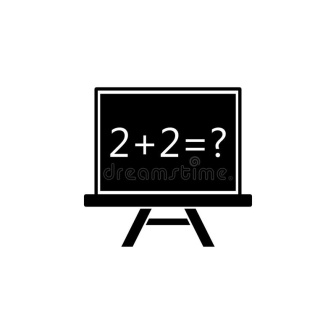In a dystopian future, how might this image be interpreted? In a dystopian future, this image could take on a more somber tone. The chalkboard standing alone in a dilapidated, abandoned classroom could symbolize the remnants of a once-thriving education system. The equation '2 + 2 = ?' might represent the lost simplicity and innocence of the past, now overlaid with a sense of hopelessness and decay. The question mark could embody the uncertainties and relentless search for answers in a world where knowledge and truth have become scarce. This scene could serve as a powerful reminder of the importance of education and the fragility of human achievements in the face of societal collapse.  We found this chalkboard in an ancient alien ruin. What does it tell us about the alien civilization? Discovering this chalkboard in an ancient alien ruin suggests that the alien civilization valued knowledge and education. The presence of a basic arithmetic equation like '2 + 2 = ?' indicates that, although they might have been highly advanced, they also taught and preserved fundamental principles of mathematics. It shows a parallel in the quest for understanding and learning that transcends human boundaries, suggesting that the pursuit of knowledge is a universal trait. This artifact could be a key to unraveling how their society was structured, their approach to teaching, and might even hint at commonalities in learning and logic that we share with them. 